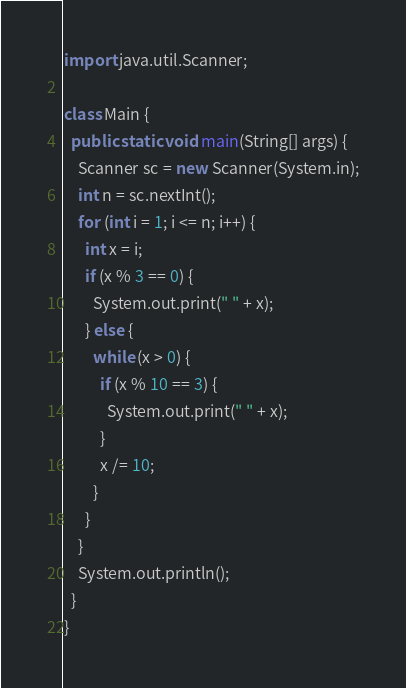Convert code to text. <code><loc_0><loc_0><loc_500><loc_500><_Java_>import java.util.Scanner;

class Main {
  public static void main(String[] args) {
    Scanner sc = new Scanner(System.in);
    int n = sc.nextInt();
    for (int i = 1; i <= n; i++) {
      int x = i;
      if (x % 3 == 0) {
        System.out.print(" " + x);
      } else {
        while (x > 0) {
          if (x % 10 == 3) {
            System.out.print(" " + x);
          }
          x /= 10;
        }
      }
    }
    System.out.println();
  }
}

</code> 